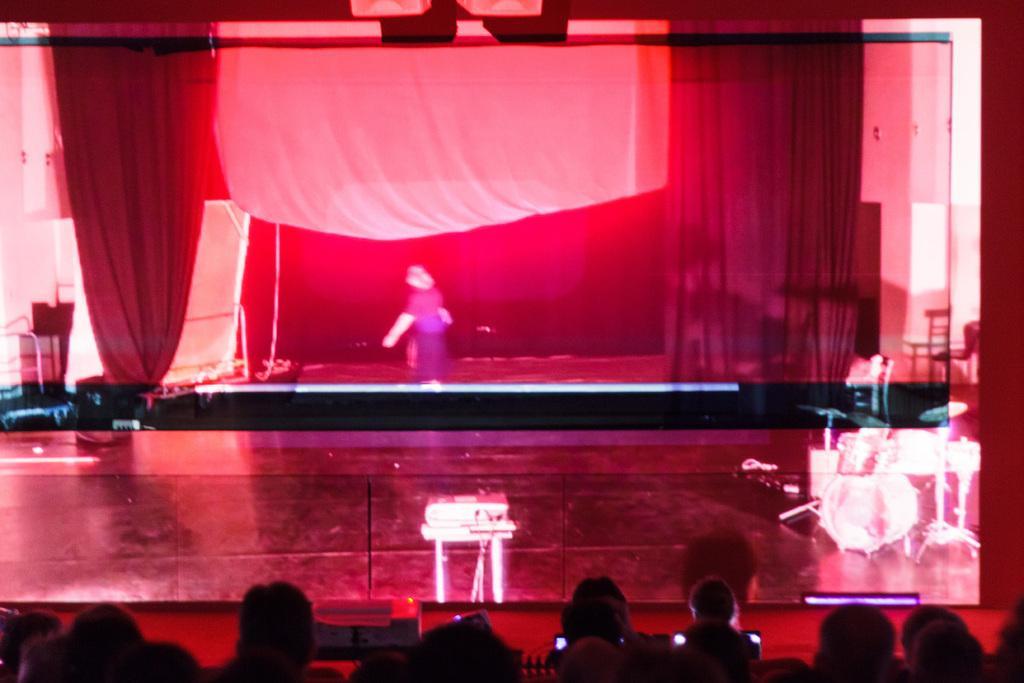Could you give a brief overview of what you see in this image? At the bottom of the image we can see a few people are sitting and few people are holding some objects. In the center of the image, we can see one stage. On the stage, we can see one person standing. In the background there is a wall, carpet, curtains, chairs, few musical instruments, one table, red color objects and a few other objects. 